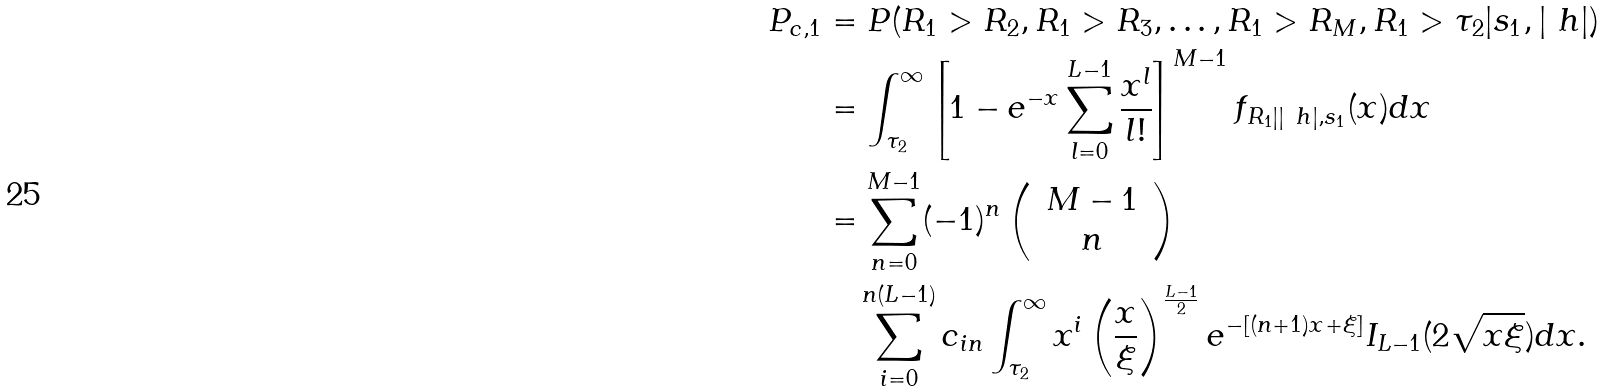Convert formula to latex. <formula><loc_0><loc_0><loc_500><loc_500>P _ { c , 1 } & = P ( R _ { 1 } > R _ { 2 } , R _ { 1 } > R _ { 3 } , \dots , R _ { 1 } > R _ { M } , R _ { 1 } > \tau _ { 2 } | s _ { 1 } , | \ h | ) \\ & = \int _ { \tau _ { 2 } } ^ { \infty } \left [ 1 - e ^ { - x } \sum _ { l = 0 } ^ { L - 1 } \frac { x ^ { l } } { l ! } \right ] ^ { M - 1 } f _ { R _ { 1 } | | \ h | , s _ { 1 } } ( x ) d x \\ & = \sum _ { n = 0 } ^ { M - 1 } ( - 1 ) ^ { n } \left ( \, \begin{array} { c c } M - 1 \\ n \end{array} \, \right ) \\ & \quad \sum _ { i = 0 } ^ { n ( L - 1 ) } c _ { i n } \int _ { \tau _ { 2 } } ^ { \infty } x ^ { i } \left ( \frac { x } { \xi } \right ) ^ { \frac { L - 1 } { 2 } } e ^ { - [ ( n + 1 ) x + \xi ] } I _ { L - 1 } ( 2 \sqrt { x \xi } ) d x .</formula> 